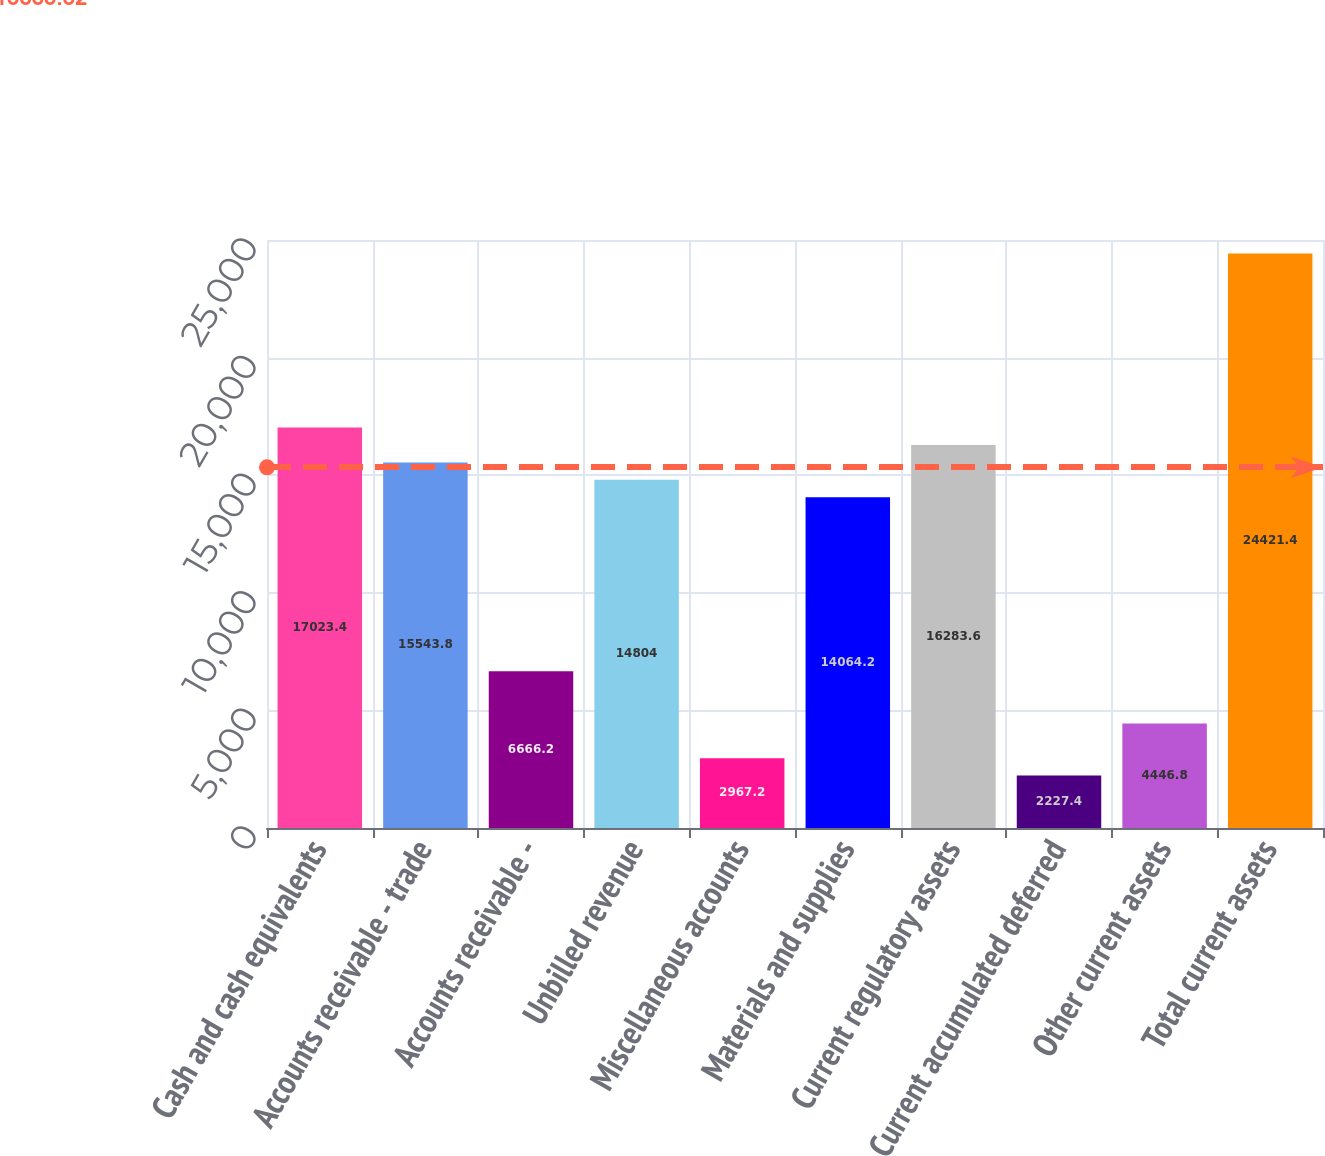Convert chart to OTSL. <chart><loc_0><loc_0><loc_500><loc_500><bar_chart><fcel>Cash and cash equivalents<fcel>Accounts receivable - trade<fcel>Accounts receivable -<fcel>Unbilled revenue<fcel>Miscellaneous accounts<fcel>Materials and supplies<fcel>Current regulatory assets<fcel>Current accumulated deferred<fcel>Other current assets<fcel>Total current assets<nl><fcel>17023.4<fcel>15543.8<fcel>6666.2<fcel>14804<fcel>2967.2<fcel>14064.2<fcel>16283.6<fcel>2227.4<fcel>4446.8<fcel>24421.4<nl></chart> 